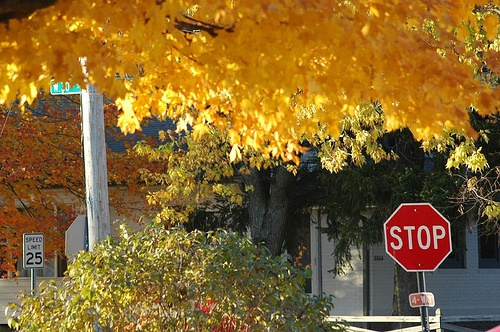Describe the objects in this image and their specific colors. I can see a stop sign in black, brown, lightpink, darkgray, and maroon tones in this image. 